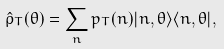<formula> <loc_0><loc_0><loc_500><loc_500>\hat { \rho } _ { T } ( \theta ) = \sum _ { n } p _ { T } ( n ) | n , \theta \rangle \langle n , \theta | ,</formula> 